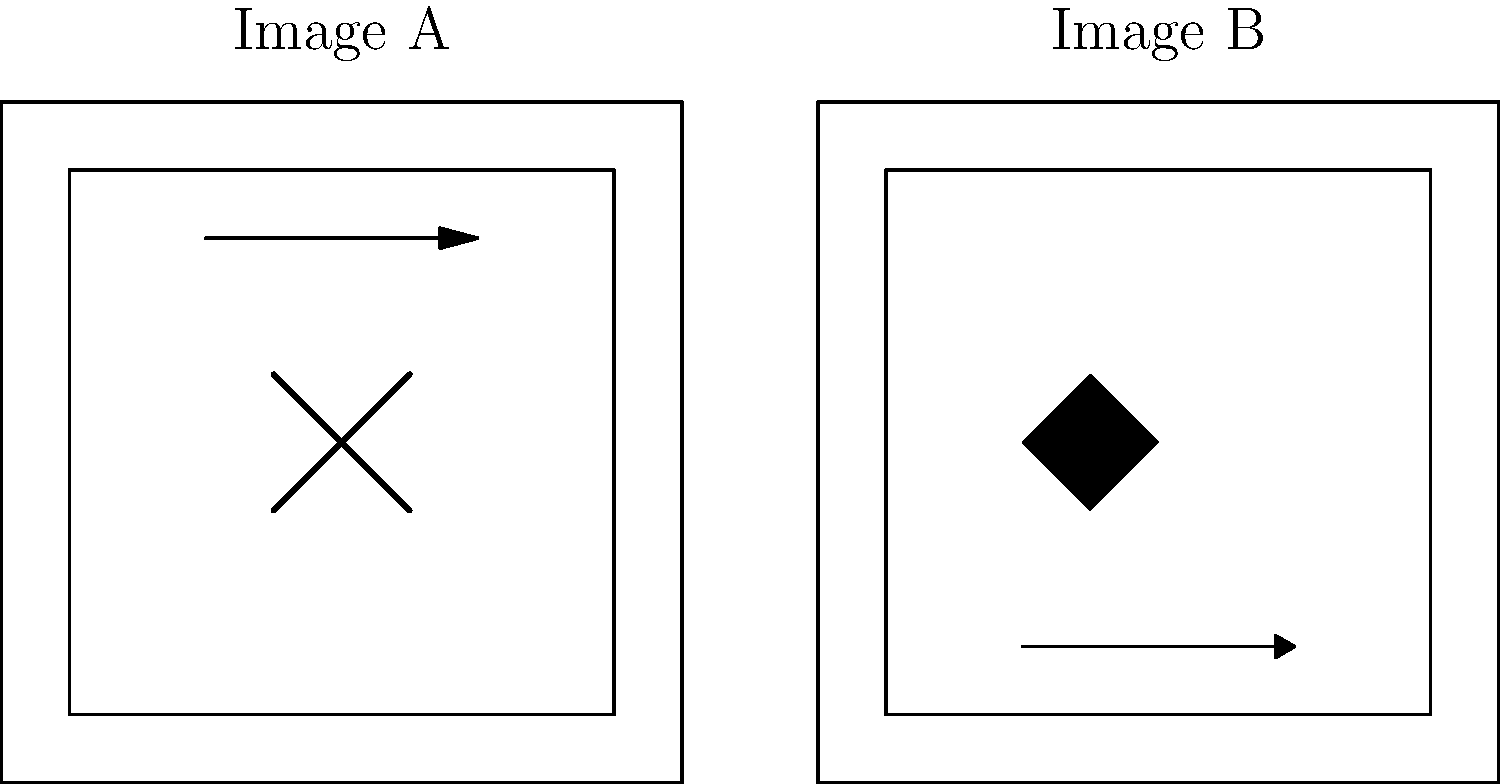In this thrilling scene comparison from a psychological thriller, how many distinct differences can you spot between Image A and Image B? To solve this visual intelligence test, let's analyze the differences between Image A and Image B step-by-step:

1. Center element: 
   - Image A: An "X" shape in the center
   - Image B: A diamond shape in the center
   Difference count: 1

2. Arrow direction:
   - Image A: A straight arrow pointing right at the bottom
   - Image B: A curved arrow pointing right at the top
   Difference count: 2

3. Arrow position:
   - Image A: Arrow located at the bottom of the image
   - Image B: Arrow located at the top of the image
   Difference count: 3

These are the three distinct differences between the two images. Each difference involves a change in shape or position of an element within the scene, which is typical of the subtle visual cues often used in thriller films to create tension or foreshadow plot developments.
Answer: 3 differences 